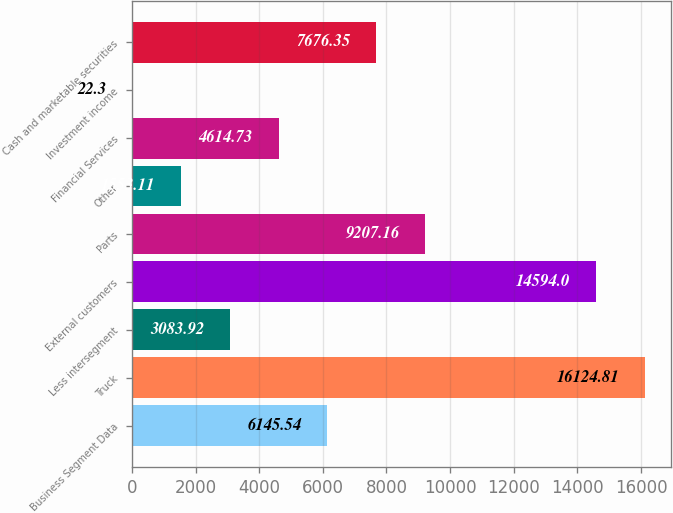<chart> <loc_0><loc_0><loc_500><loc_500><bar_chart><fcel>Business Segment Data<fcel>Truck<fcel>Less intersegment<fcel>External customers<fcel>Parts<fcel>Other<fcel>Financial Services<fcel>Investment income<fcel>Cash and marketable securities<nl><fcel>6145.54<fcel>16124.8<fcel>3083.92<fcel>14594<fcel>9207.16<fcel>1553.11<fcel>4614.73<fcel>22.3<fcel>7676.35<nl></chart> 